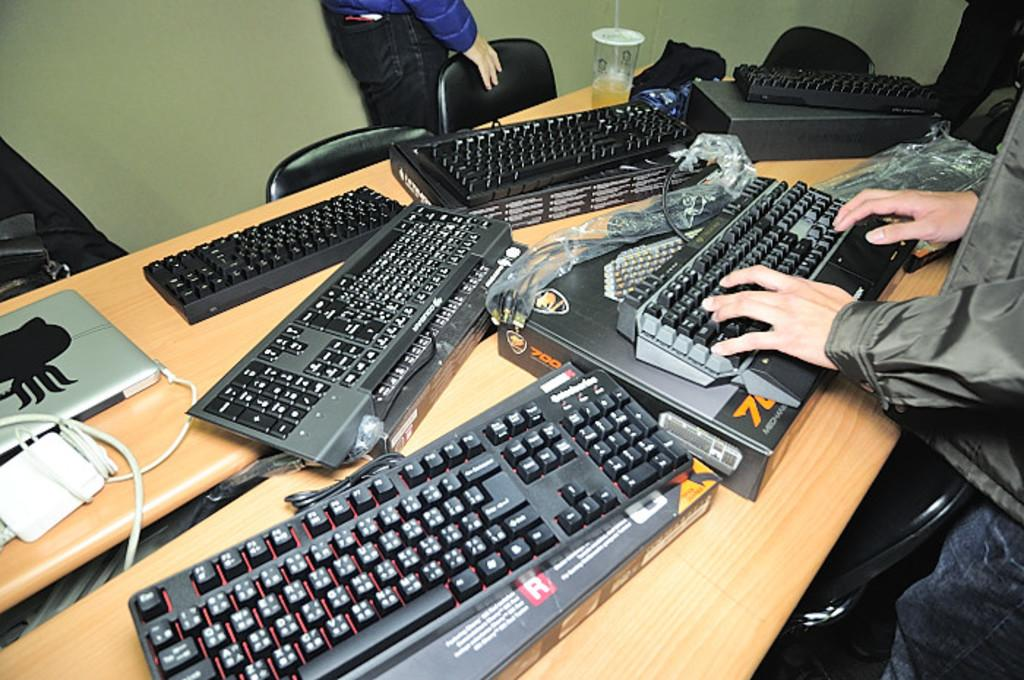<image>
Offer a succinct explanation of the picture presented. A man's hands are showing using the keyboard on the box labeled "700" and something, but it's obscured. 